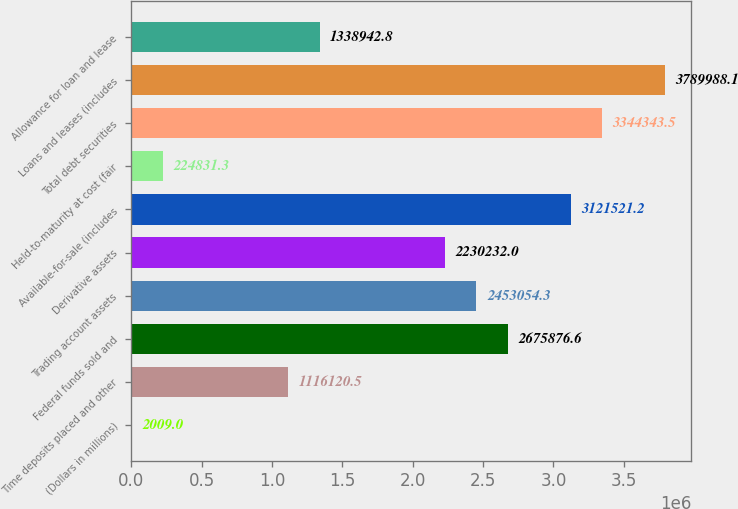Convert chart. <chart><loc_0><loc_0><loc_500><loc_500><bar_chart><fcel>(Dollars in millions)<fcel>Time deposits placed and other<fcel>Federal funds sold and<fcel>Trading account assets<fcel>Derivative assets<fcel>Available-for-sale (includes<fcel>Held-to-maturity at cost (fair<fcel>Total debt securities<fcel>Loans and leases (includes<fcel>Allowance for loan and lease<nl><fcel>2009<fcel>1.11612e+06<fcel>2.67588e+06<fcel>2.45305e+06<fcel>2.23023e+06<fcel>3.12152e+06<fcel>224831<fcel>3.34434e+06<fcel>3.78999e+06<fcel>1.33894e+06<nl></chart> 